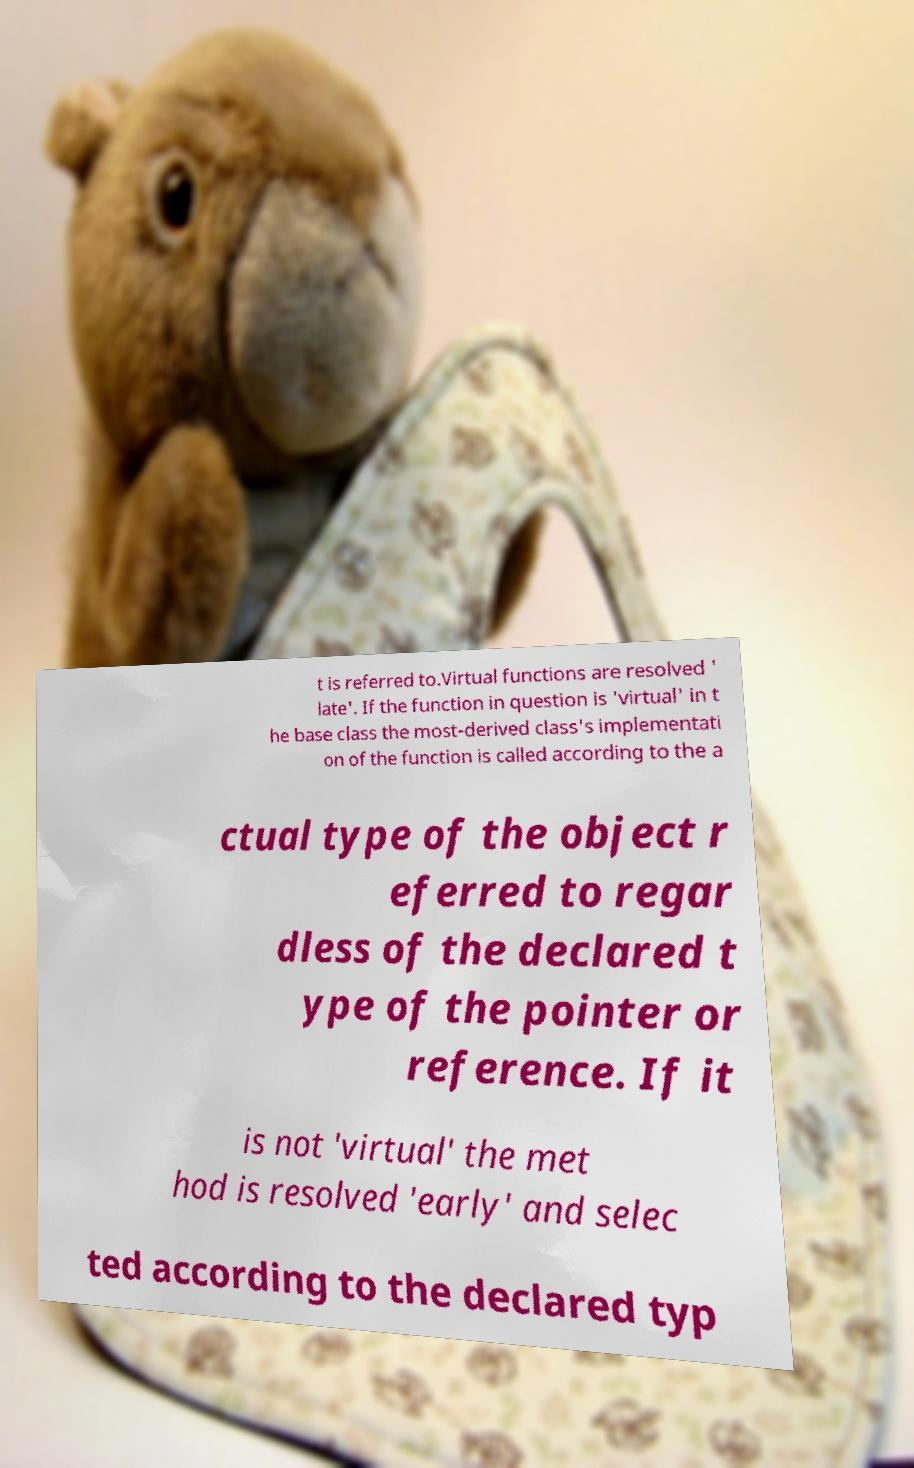Please read and relay the text visible in this image. What does it say? t is referred to.Virtual functions are resolved ' late'. If the function in question is 'virtual' in t he base class the most-derived class's implementati on of the function is called according to the a ctual type of the object r eferred to regar dless of the declared t ype of the pointer or reference. If it is not 'virtual' the met hod is resolved 'early' and selec ted according to the declared typ 